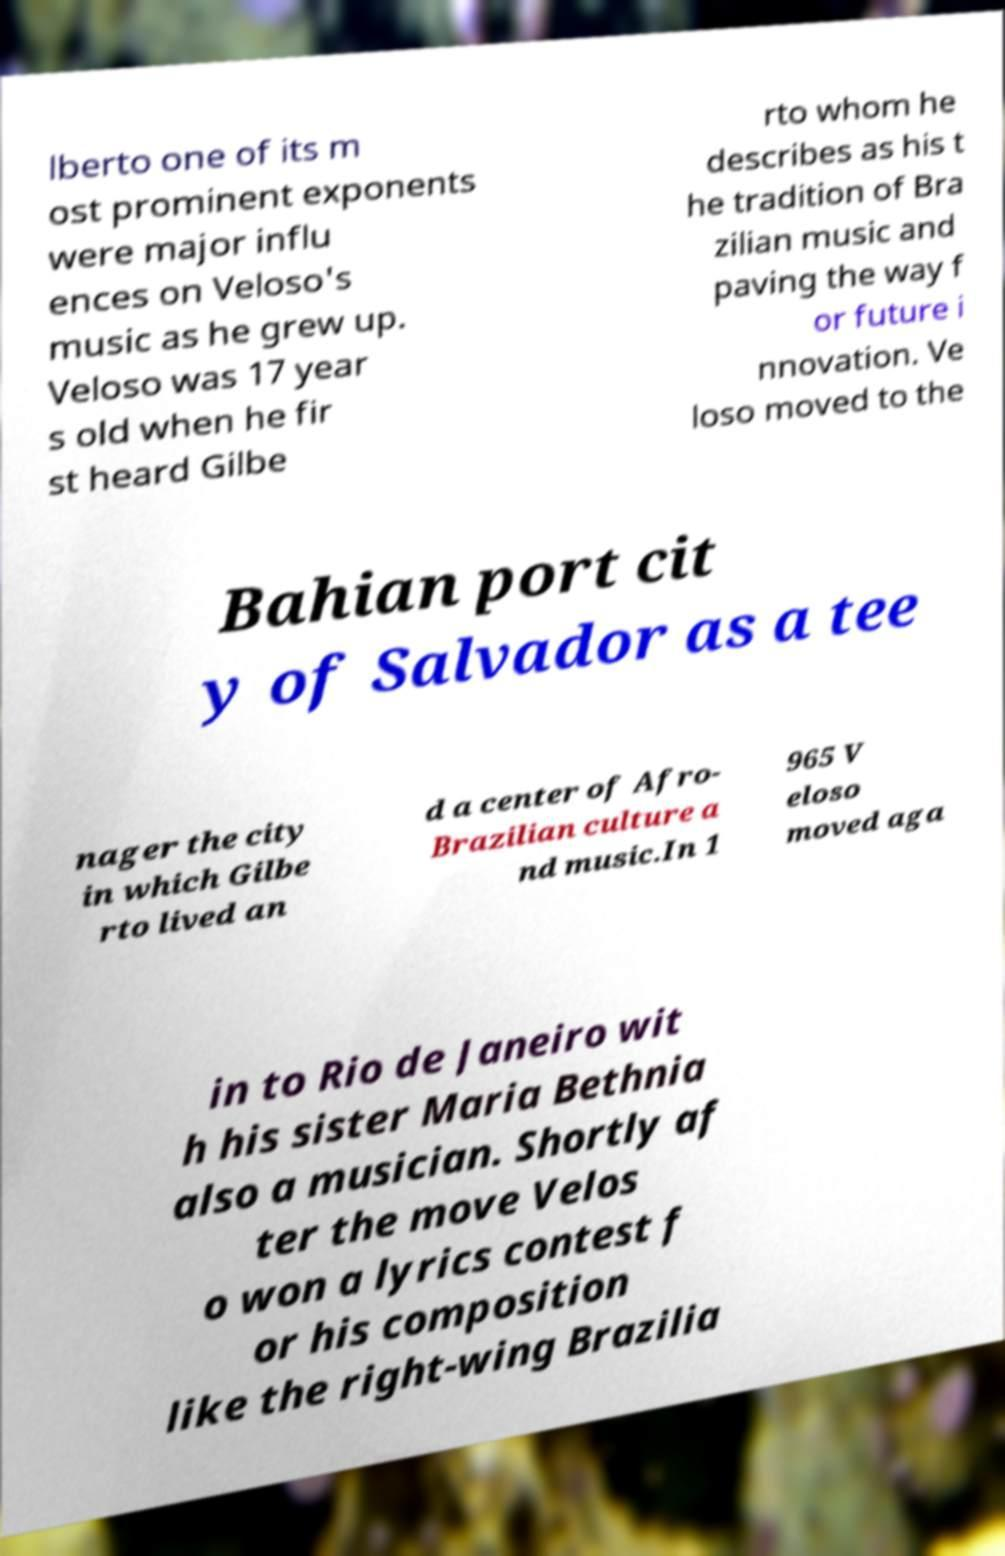There's text embedded in this image that I need extracted. Can you transcribe it verbatim? lberto one of its m ost prominent exponents were major influ ences on Veloso's music as he grew up. Veloso was 17 year s old when he fir st heard Gilbe rto whom he describes as his t he tradition of Bra zilian music and paving the way f or future i nnovation. Ve loso moved to the Bahian port cit y of Salvador as a tee nager the city in which Gilbe rto lived an d a center of Afro- Brazilian culture a nd music.In 1 965 V eloso moved aga in to Rio de Janeiro wit h his sister Maria Bethnia also a musician. Shortly af ter the move Velos o won a lyrics contest f or his composition like the right-wing Brazilia 